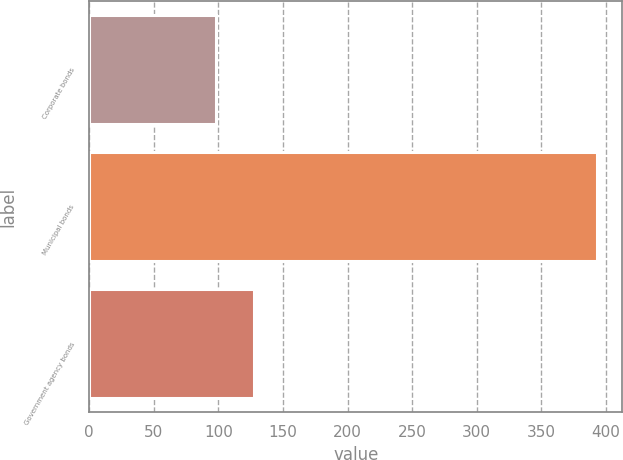Convert chart to OTSL. <chart><loc_0><loc_0><loc_500><loc_500><bar_chart><fcel>Corporate bonds<fcel>Municipal bonds<fcel>Government agency bonds<nl><fcel>98<fcel>393<fcel>127.5<nl></chart> 